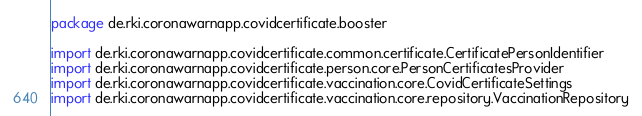Convert code to text. <code><loc_0><loc_0><loc_500><loc_500><_Kotlin_>package de.rki.coronawarnapp.covidcertificate.booster

import de.rki.coronawarnapp.covidcertificate.common.certificate.CertificatePersonIdentifier
import de.rki.coronawarnapp.covidcertificate.person.core.PersonCertificatesProvider
import de.rki.coronawarnapp.covidcertificate.vaccination.core.CovidCertificateSettings
import de.rki.coronawarnapp.covidcertificate.vaccination.core.repository.VaccinationRepository</code> 